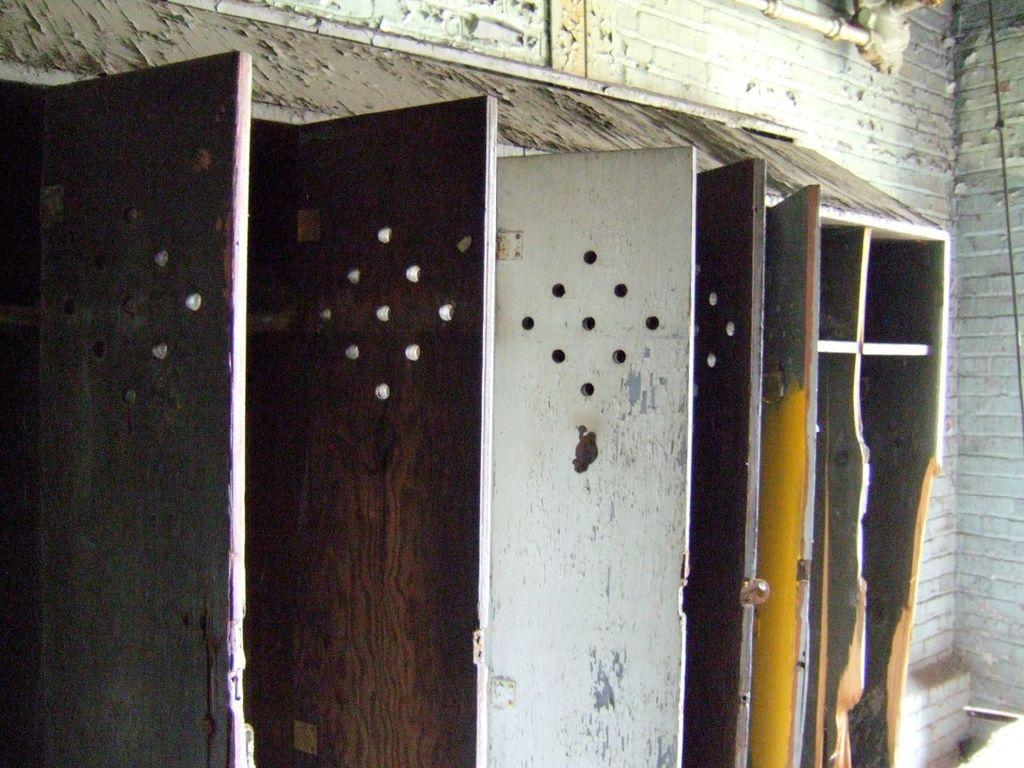What type of doors are visible in the image? There are iron doors in the image. What structure can be seen behind the doors? There is a wall in the image. Is there any plumbing visible in the image? Yes, there is a connected pipe in the image. How many eggs are tied in a knot on the wall in the image? There are no eggs or knots present in the image; it features iron doors, a wall, and a connected pipe. 